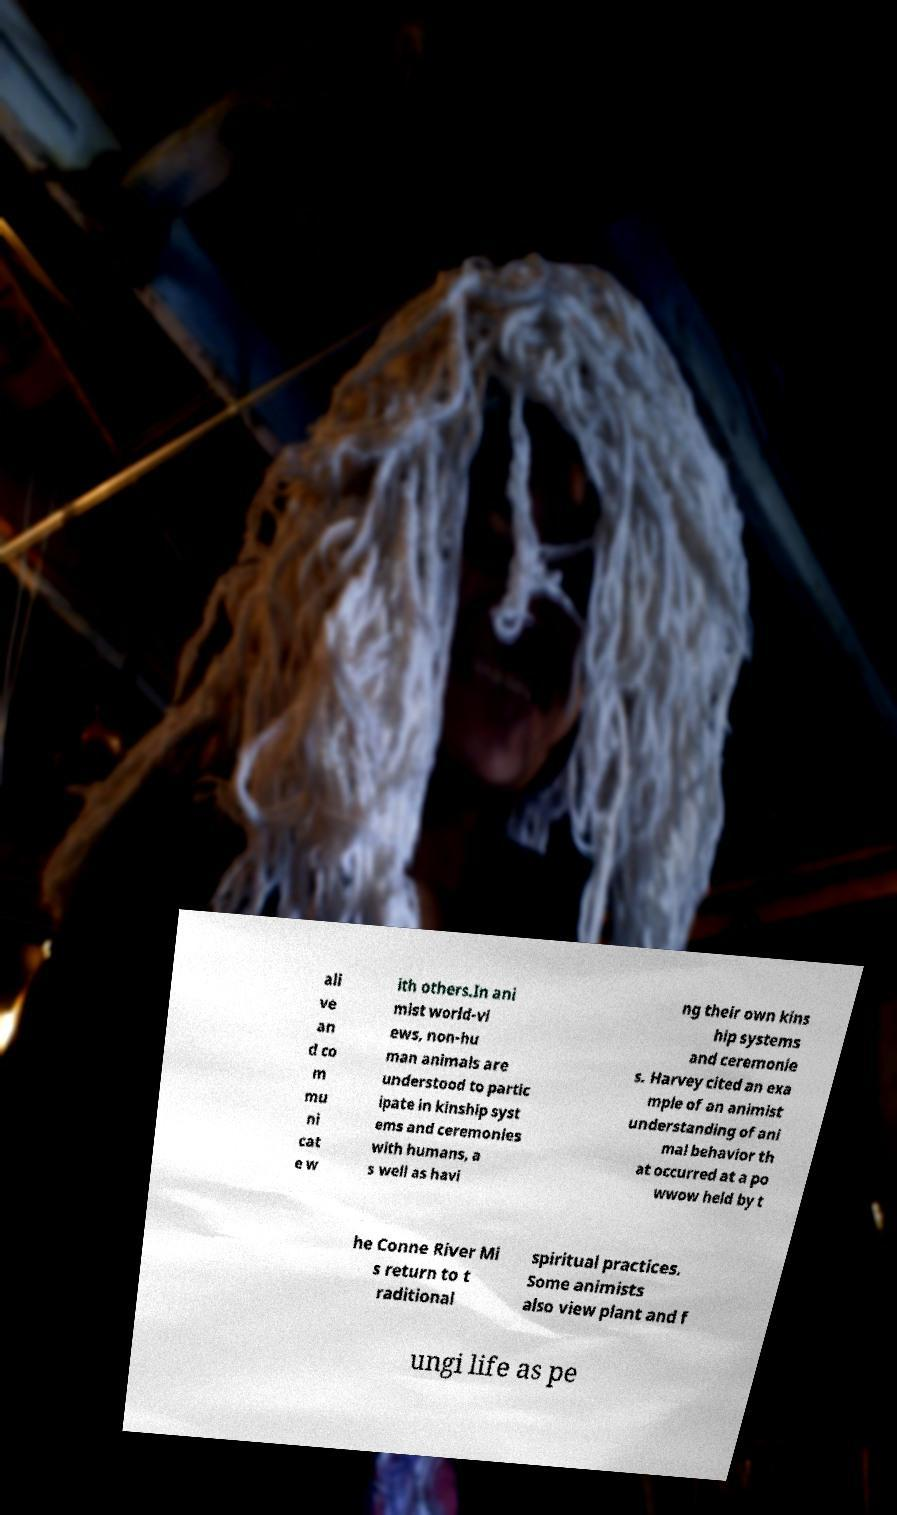Please read and relay the text visible in this image. What does it say? ali ve an d co m mu ni cat e w ith others.In ani mist world-vi ews, non-hu man animals are understood to partic ipate in kinship syst ems and ceremonies with humans, a s well as havi ng their own kins hip systems and ceremonie s. Harvey cited an exa mple of an animist understanding of ani mal behavior th at occurred at a po wwow held by t he Conne River Mi s return to t raditional spiritual practices. Some animists also view plant and f ungi life as pe 